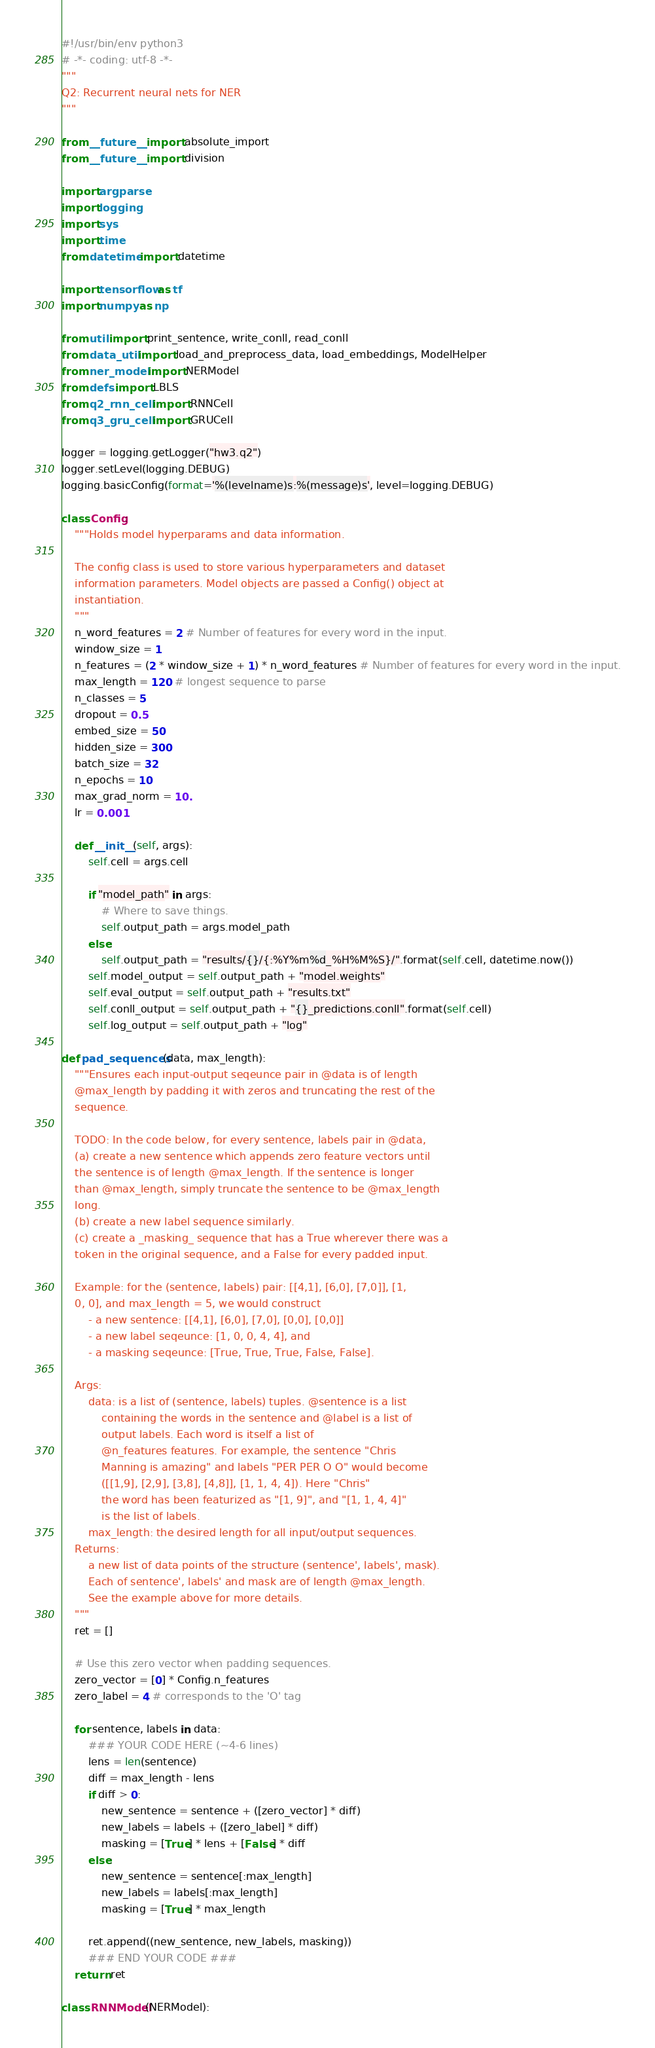Convert code to text. <code><loc_0><loc_0><loc_500><loc_500><_Python_>#!/usr/bin/env python3
# -*- coding: utf-8 -*-
"""
Q2: Recurrent neural nets for NER
"""

from __future__ import absolute_import
from __future__ import division

import argparse
import logging
import sys
import time
from datetime import datetime

import tensorflow as tf
import numpy as np

from util import print_sentence, write_conll, read_conll
from data_util import load_and_preprocess_data, load_embeddings, ModelHelper
from ner_model import NERModel
from defs import LBLS
from q2_rnn_cell import RNNCell
from q3_gru_cell import GRUCell

logger = logging.getLogger("hw3.q2")
logger.setLevel(logging.DEBUG)
logging.basicConfig(format='%(levelname)s:%(message)s', level=logging.DEBUG)

class Config:
    """Holds model hyperparams and data information.

    The config class is used to store various hyperparameters and dataset
    information parameters. Model objects are passed a Config() object at
    instantiation.
    """
    n_word_features = 2 # Number of features for every word in the input.
    window_size = 1
    n_features = (2 * window_size + 1) * n_word_features # Number of features for every word in the input.
    max_length = 120 # longest sequence to parse
    n_classes = 5
    dropout = 0.5
    embed_size = 50
    hidden_size = 300
    batch_size = 32
    n_epochs = 10
    max_grad_norm = 10.
    lr = 0.001

    def __init__(self, args):
        self.cell = args.cell

        if "model_path" in args:
            # Where to save things.
            self.output_path = args.model_path
        else:
            self.output_path = "results/{}/{:%Y%m%d_%H%M%S}/".format(self.cell, datetime.now())
        self.model_output = self.output_path + "model.weights"
        self.eval_output = self.output_path + "results.txt"
        self.conll_output = self.output_path + "{}_predictions.conll".format(self.cell)
        self.log_output = self.output_path + "log"

def pad_sequences(data, max_length):
    """Ensures each input-output seqeunce pair in @data is of length
    @max_length by padding it with zeros and truncating the rest of the
    sequence.

    TODO: In the code below, for every sentence, labels pair in @data,
    (a) create a new sentence which appends zero feature vectors until
    the sentence is of length @max_length. If the sentence is longer
    than @max_length, simply truncate the sentence to be @max_length
    long.
    (b) create a new label sequence similarly.
    (c) create a _masking_ sequence that has a True wherever there was a
    token in the original sequence, and a False for every padded input.

    Example: for the (sentence, labels) pair: [[4,1], [6,0], [7,0]], [1,
    0, 0], and max_length = 5, we would construct
        - a new sentence: [[4,1], [6,0], [7,0], [0,0], [0,0]]
        - a new label seqeunce: [1, 0, 0, 4, 4], and
        - a masking seqeunce: [True, True, True, False, False].

    Args:
        data: is a list of (sentence, labels) tuples. @sentence is a list
            containing the words in the sentence and @label is a list of
            output labels. Each word is itself a list of
            @n_features features. For example, the sentence "Chris
            Manning is amazing" and labels "PER PER O O" would become
            ([[1,9], [2,9], [3,8], [4,8]], [1, 1, 4, 4]). Here "Chris"
            the word has been featurized as "[1, 9]", and "[1, 1, 4, 4]"
            is the list of labels. 
        max_length: the desired length for all input/output sequences.
    Returns:
        a new list of data points of the structure (sentence', labels', mask).
        Each of sentence', labels' and mask are of length @max_length.
        See the example above for more details.
    """
    ret = []

    # Use this zero vector when padding sequences.
    zero_vector = [0] * Config.n_features
    zero_label = 4 # corresponds to the 'O' tag

    for sentence, labels in data:
        ### YOUR CODE HERE (~4-6 lines)
        lens = len(sentence)
        diff = max_length - lens
        if diff > 0:
            new_sentence = sentence + ([zero_vector] * diff)
            new_labels = labels + ([zero_label] * diff)
            masking = [True] * lens + [False] * diff
        else:
            new_sentence = sentence[:max_length]
            new_labels = labels[:max_length]
            masking = [True] * max_length
        
        ret.append((new_sentence, new_labels, masking))
        ### END YOUR CODE ###
    return ret

class RNNModel(NERModel):</code> 